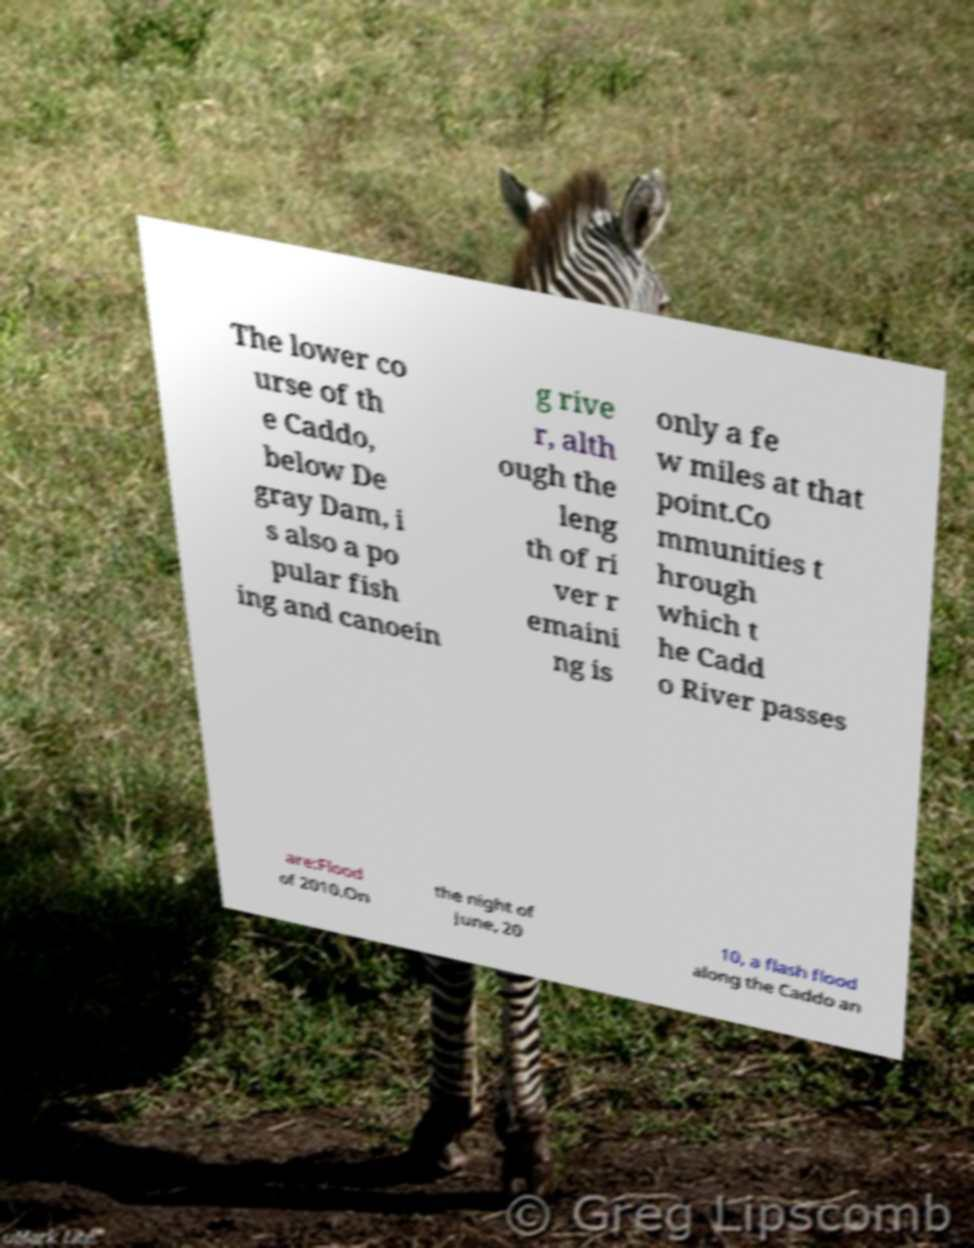Could you extract and type out the text from this image? The lower co urse of th e Caddo, below De gray Dam, i s also a po pular fish ing and canoein g rive r, alth ough the leng th of ri ver r emaini ng is only a fe w miles at that point.Co mmunities t hrough which t he Cadd o River passes are:Flood of 2010.On the night of June, 20 10, a flash flood along the Caddo an 